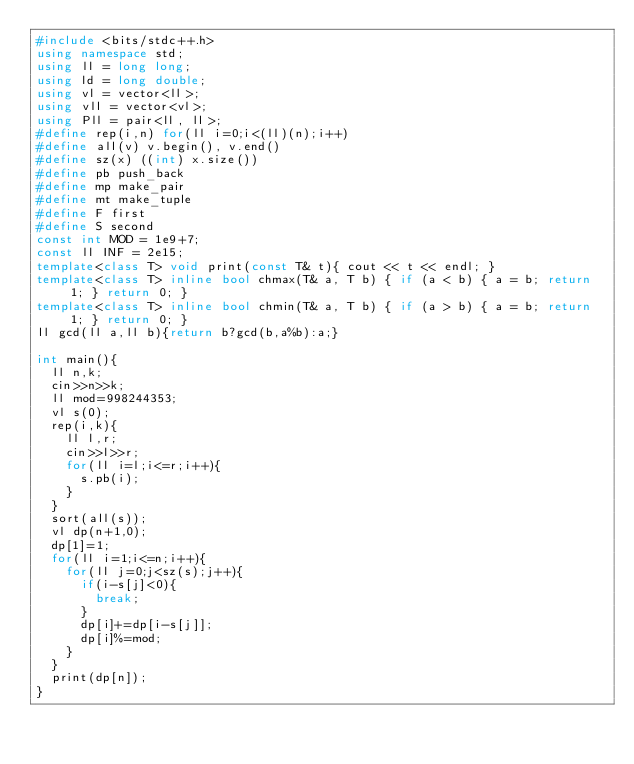<code> <loc_0><loc_0><loc_500><loc_500><_C++_>#include <bits/stdc++.h>
using namespace std;
using ll = long long;
using ld = long double;
using vl = vector<ll>;
using vll = vector<vl>;
using Pll = pair<ll, ll>;
#define rep(i,n) for(ll i=0;i<(ll)(n);i++)
#define all(v) v.begin(), v.end()
#define sz(x) ((int) x.size())
#define pb push_back
#define mp make_pair
#define mt make_tuple
#define F first
#define S second
const int MOD = 1e9+7;
const ll INF = 2e15;
template<class T> void print(const T& t){ cout << t << endl; }
template<class T> inline bool chmax(T& a, T b) { if (a < b) { a = b; return 1; } return 0; }
template<class T> inline bool chmin(T& a, T b) { if (a > b) { a = b; return 1; } return 0; }
ll gcd(ll a,ll b){return b?gcd(b,a%b):a;}

int main(){
  ll n,k;
  cin>>n>>k;
  ll mod=998244353;
  vl s(0);
  rep(i,k){
    ll l,r;
    cin>>l>>r;
    for(ll i=l;i<=r;i++){
      s.pb(i);
    }
  }
  sort(all(s));
  vl dp(n+1,0);
  dp[1]=1;
  for(ll i=1;i<=n;i++){
    for(ll j=0;j<sz(s);j++){
      if(i-s[j]<0){
        break;
      }
      dp[i]+=dp[i-s[j]];
      dp[i]%=mod;
    }
  }
  print(dp[n]);
}
</code> 